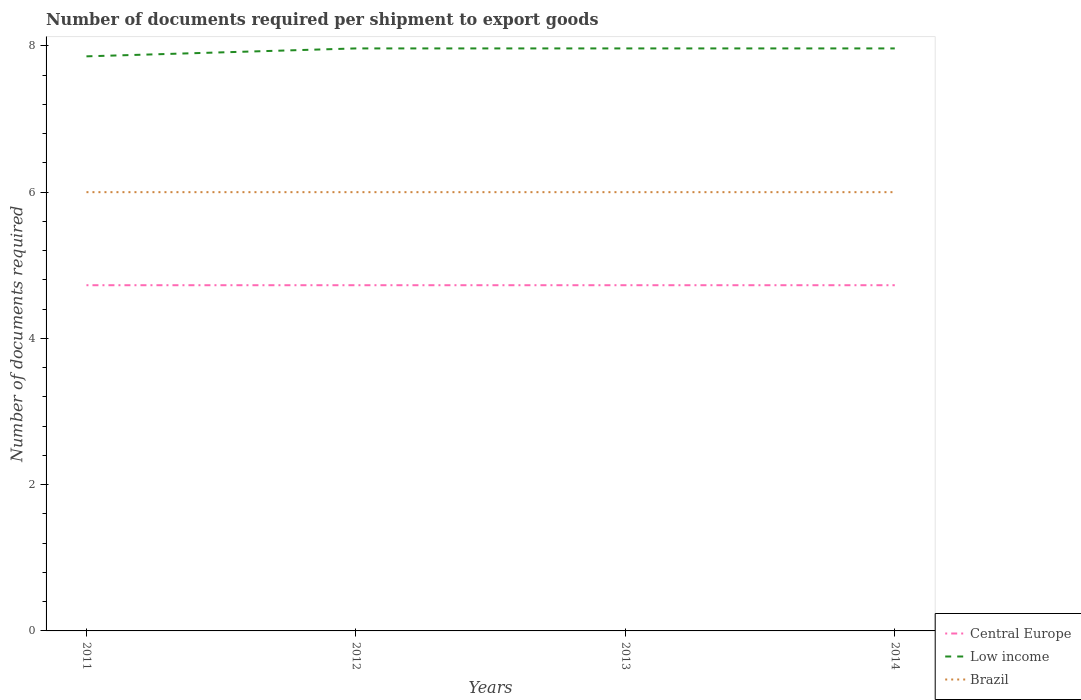How many different coloured lines are there?
Provide a succinct answer. 3. Does the line corresponding to Brazil intersect with the line corresponding to Central Europe?
Your answer should be compact. No. Across all years, what is the maximum number of documents required per shipment to export goods in Low income?
Your answer should be very brief. 7.86. What is the total number of documents required per shipment to export goods in Central Europe in the graph?
Your response must be concise. 0. What is the difference between the highest and the lowest number of documents required per shipment to export goods in Low income?
Offer a terse response. 3. How many years are there in the graph?
Keep it short and to the point. 4. What is the difference between two consecutive major ticks on the Y-axis?
Your answer should be very brief. 2. Does the graph contain any zero values?
Provide a short and direct response. No. Does the graph contain grids?
Offer a very short reply. No. How are the legend labels stacked?
Ensure brevity in your answer.  Vertical. What is the title of the graph?
Provide a short and direct response. Number of documents required per shipment to export goods. Does "High income" appear as one of the legend labels in the graph?
Provide a short and direct response. No. What is the label or title of the X-axis?
Your response must be concise. Years. What is the label or title of the Y-axis?
Offer a terse response. Number of documents required. What is the Number of documents required of Central Europe in 2011?
Provide a short and direct response. 4.73. What is the Number of documents required in Low income in 2011?
Your response must be concise. 7.86. What is the Number of documents required of Central Europe in 2012?
Your response must be concise. 4.73. What is the Number of documents required in Low income in 2012?
Offer a terse response. 7.97. What is the Number of documents required of Brazil in 2012?
Your answer should be very brief. 6. What is the Number of documents required of Central Europe in 2013?
Ensure brevity in your answer.  4.73. What is the Number of documents required in Low income in 2013?
Offer a very short reply. 7.97. What is the Number of documents required of Brazil in 2013?
Offer a terse response. 6. What is the Number of documents required of Central Europe in 2014?
Make the answer very short. 4.73. What is the Number of documents required of Low income in 2014?
Ensure brevity in your answer.  7.97. What is the Number of documents required in Brazil in 2014?
Provide a short and direct response. 6. Across all years, what is the maximum Number of documents required in Central Europe?
Your answer should be very brief. 4.73. Across all years, what is the maximum Number of documents required in Low income?
Provide a succinct answer. 7.97. Across all years, what is the maximum Number of documents required in Brazil?
Your answer should be compact. 6. Across all years, what is the minimum Number of documents required of Central Europe?
Give a very brief answer. 4.73. Across all years, what is the minimum Number of documents required in Low income?
Make the answer very short. 7.86. What is the total Number of documents required of Central Europe in the graph?
Offer a very short reply. 18.91. What is the total Number of documents required in Low income in the graph?
Offer a terse response. 31.75. What is the total Number of documents required of Brazil in the graph?
Offer a very short reply. 24. What is the difference between the Number of documents required in Central Europe in 2011 and that in 2012?
Offer a very short reply. 0. What is the difference between the Number of documents required in Low income in 2011 and that in 2012?
Your response must be concise. -0.11. What is the difference between the Number of documents required in Central Europe in 2011 and that in 2013?
Your response must be concise. 0. What is the difference between the Number of documents required of Low income in 2011 and that in 2013?
Give a very brief answer. -0.11. What is the difference between the Number of documents required in Central Europe in 2011 and that in 2014?
Keep it short and to the point. 0. What is the difference between the Number of documents required in Low income in 2011 and that in 2014?
Give a very brief answer. -0.11. What is the difference between the Number of documents required of Low income in 2012 and that in 2013?
Ensure brevity in your answer.  0. What is the difference between the Number of documents required in Brazil in 2012 and that in 2013?
Your answer should be compact. 0. What is the difference between the Number of documents required in Brazil in 2012 and that in 2014?
Offer a very short reply. 0. What is the difference between the Number of documents required in Low income in 2013 and that in 2014?
Provide a succinct answer. 0. What is the difference between the Number of documents required of Central Europe in 2011 and the Number of documents required of Low income in 2012?
Your response must be concise. -3.24. What is the difference between the Number of documents required in Central Europe in 2011 and the Number of documents required in Brazil in 2012?
Keep it short and to the point. -1.27. What is the difference between the Number of documents required of Low income in 2011 and the Number of documents required of Brazil in 2012?
Make the answer very short. 1.86. What is the difference between the Number of documents required in Central Europe in 2011 and the Number of documents required in Low income in 2013?
Offer a very short reply. -3.24. What is the difference between the Number of documents required of Central Europe in 2011 and the Number of documents required of Brazil in 2013?
Provide a short and direct response. -1.27. What is the difference between the Number of documents required in Low income in 2011 and the Number of documents required in Brazil in 2013?
Keep it short and to the point. 1.86. What is the difference between the Number of documents required in Central Europe in 2011 and the Number of documents required in Low income in 2014?
Your answer should be very brief. -3.24. What is the difference between the Number of documents required of Central Europe in 2011 and the Number of documents required of Brazil in 2014?
Keep it short and to the point. -1.27. What is the difference between the Number of documents required in Low income in 2011 and the Number of documents required in Brazil in 2014?
Your answer should be compact. 1.86. What is the difference between the Number of documents required of Central Europe in 2012 and the Number of documents required of Low income in 2013?
Your response must be concise. -3.24. What is the difference between the Number of documents required of Central Europe in 2012 and the Number of documents required of Brazil in 2013?
Offer a very short reply. -1.27. What is the difference between the Number of documents required in Low income in 2012 and the Number of documents required in Brazil in 2013?
Offer a terse response. 1.97. What is the difference between the Number of documents required in Central Europe in 2012 and the Number of documents required in Low income in 2014?
Make the answer very short. -3.24. What is the difference between the Number of documents required in Central Europe in 2012 and the Number of documents required in Brazil in 2014?
Make the answer very short. -1.27. What is the difference between the Number of documents required in Low income in 2012 and the Number of documents required in Brazil in 2014?
Offer a terse response. 1.97. What is the difference between the Number of documents required in Central Europe in 2013 and the Number of documents required in Low income in 2014?
Provide a succinct answer. -3.24. What is the difference between the Number of documents required in Central Europe in 2013 and the Number of documents required in Brazil in 2014?
Make the answer very short. -1.27. What is the difference between the Number of documents required of Low income in 2013 and the Number of documents required of Brazil in 2014?
Give a very brief answer. 1.97. What is the average Number of documents required of Central Europe per year?
Ensure brevity in your answer.  4.73. What is the average Number of documents required in Low income per year?
Make the answer very short. 7.94. In the year 2011, what is the difference between the Number of documents required of Central Europe and Number of documents required of Low income?
Your response must be concise. -3.13. In the year 2011, what is the difference between the Number of documents required of Central Europe and Number of documents required of Brazil?
Your response must be concise. -1.27. In the year 2011, what is the difference between the Number of documents required in Low income and Number of documents required in Brazil?
Ensure brevity in your answer.  1.86. In the year 2012, what is the difference between the Number of documents required of Central Europe and Number of documents required of Low income?
Your answer should be compact. -3.24. In the year 2012, what is the difference between the Number of documents required in Central Europe and Number of documents required in Brazil?
Your answer should be compact. -1.27. In the year 2012, what is the difference between the Number of documents required of Low income and Number of documents required of Brazil?
Provide a succinct answer. 1.97. In the year 2013, what is the difference between the Number of documents required in Central Europe and Number of documents required in Low income?
Offer a terse response. -3.24. In the year 2013, what is the difference between the Number of documents required of Central Europe and Number of documents required of Brazil?
Give a very brief answer. -1.27. In the year 2013, what is the difference between the Number of documents required in Low income and Number of documents required in Brazil?
Offer a terse response. 1.97. In the year 2014, what is the difference between the Number of documents required in Central Europe and Number of documents required in Low income?
Ensure brevity in your answer.  -3.24. In the year 2014, what is the difference between the Number of documents required in Central Europe and Number of documents required in Brazil?
Ensure brevity in your answer.  -1.27. In the year 2014, what is the difference between the Number of documents required of Low income and Number of documents required of Brazil?
Offer a terse response. 1.97. What is the ratio of the Number of documents required in Low income in 2011 to that in 2012?
Keep it short and to the point. 0.99. What is the ratio of the Number of documents required in Central Europe in 2011 to that in 2013?
Ensure brevity in your answer.  1. What is the ratio of the Number of documents required in Low income in 2011 to that in 2013?
Make the answer very short. 0.99. What is the ratio of the Number of documents required in Brazil in 2011 to that in 2013?
Your answer should be compact. 1. What is the ratio of the Number of documents required in Central Europe in 2011 to that in 2014?
Your response must be concise. 1. What is the ratio of the Number of documents required in Low income in 2011 to that in 2014?
Your response must be concise. 0.99. What is the ratio of the Number of documents required of Brazil in 2011 to that in 2014?
Make the answer very short. 1. What is the ratio of the Number of documents required of Central Europe in 2012 to that in 2013?
Make the answer very short. 1. What is the ratio of the Number of documents required in Brazil in 2012 to that in 2014?
Offer a very short reply. 1. What is the ratio of the Number of documents required in Low income in 2013 to that in 2014?
Keep it short and to the point. 1. What is the difference between the highest and the second highest Number of documents required of Low income?
Provide a short and direct response. 0. What is the difference between the highest and the second highest Number of documents required of Brazil?
Keep it short and to the point. 0. What is the difference between the highest and the lowest Number of documents required of Central Europe?
Your answer should be compact. 0. What is the difference between the highest and the lowest Number of documents required of Low income?
Your response must be concise. 0.11. 